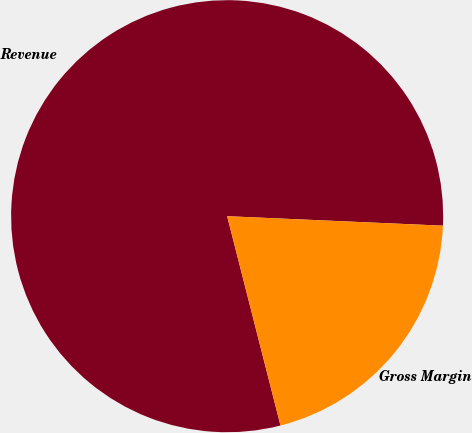<chart> <loc_0><loc_0><loc_500><loc_500><pie_chart><fcel>Revenue<fcel>Gross Margin<nl><fcel>79.67%<fcel>20.33%<nl></chart> 